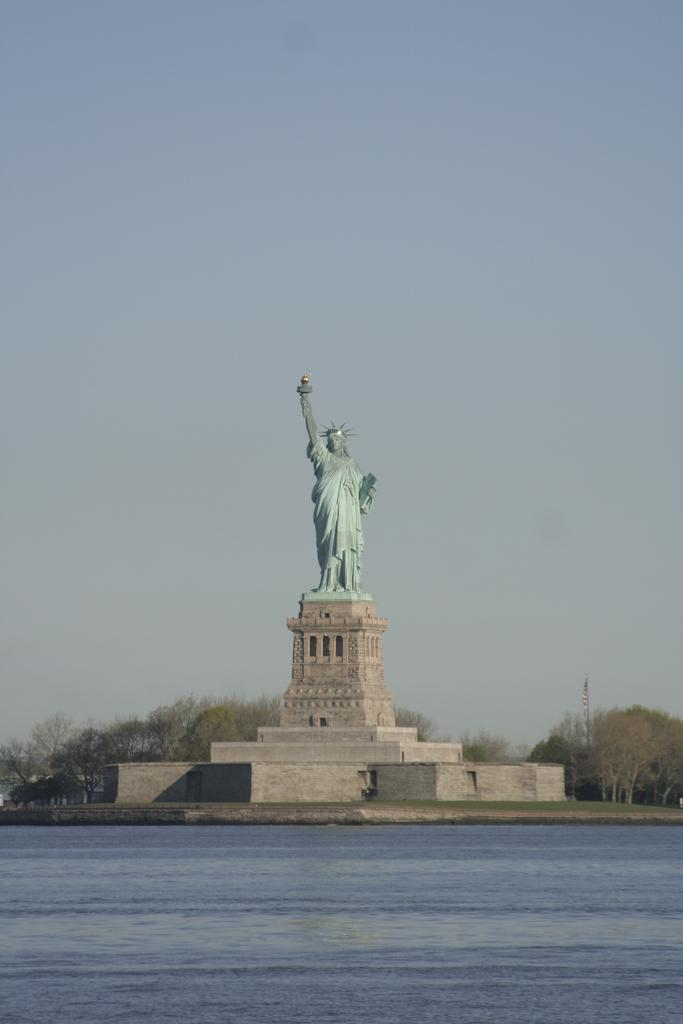What is one of the natural elements present in the image? There is water in the image. What type of vegetation can be seen in the image? There is grass and trees in the image. What man-made object is present in the image? There is a statue on a pedestal in the image. What can be seen in the background of the image? The sky is visible in the background of the image. What type of bell can be heard ringing in the image? There is no bell present in the image, and therefore no sound can be heard. 